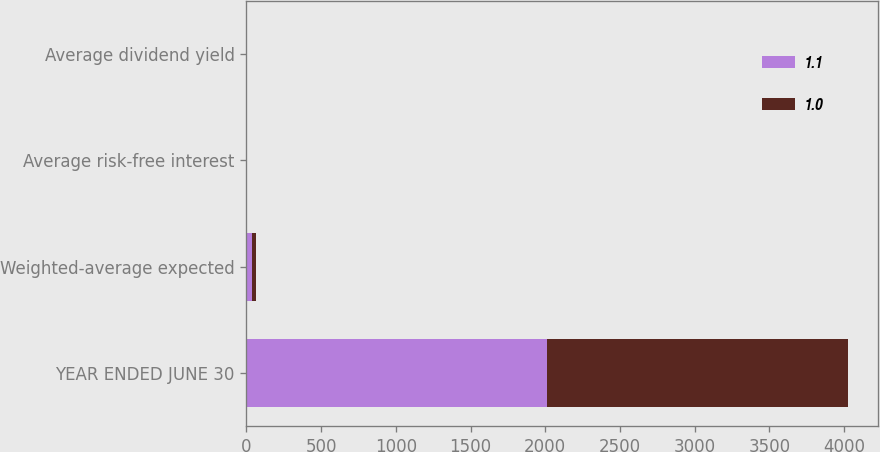<chart> <loc_0><loc_0><loc_500><loc_500><stacked_bar_chart><ecel><fcel>YEAR ENDED JUNE 30<fcel>Weighted-average expected<fcel>Average risk-free interest<fcel>Average dividend yield<nl><fcel>1.1<fcel>2013<fcel>34<fcel>1.2<fcel>1<nl><fcel>1<fcel>2011<fcel>31<fcel>2.2<fcel>1.1<nl></chart> 